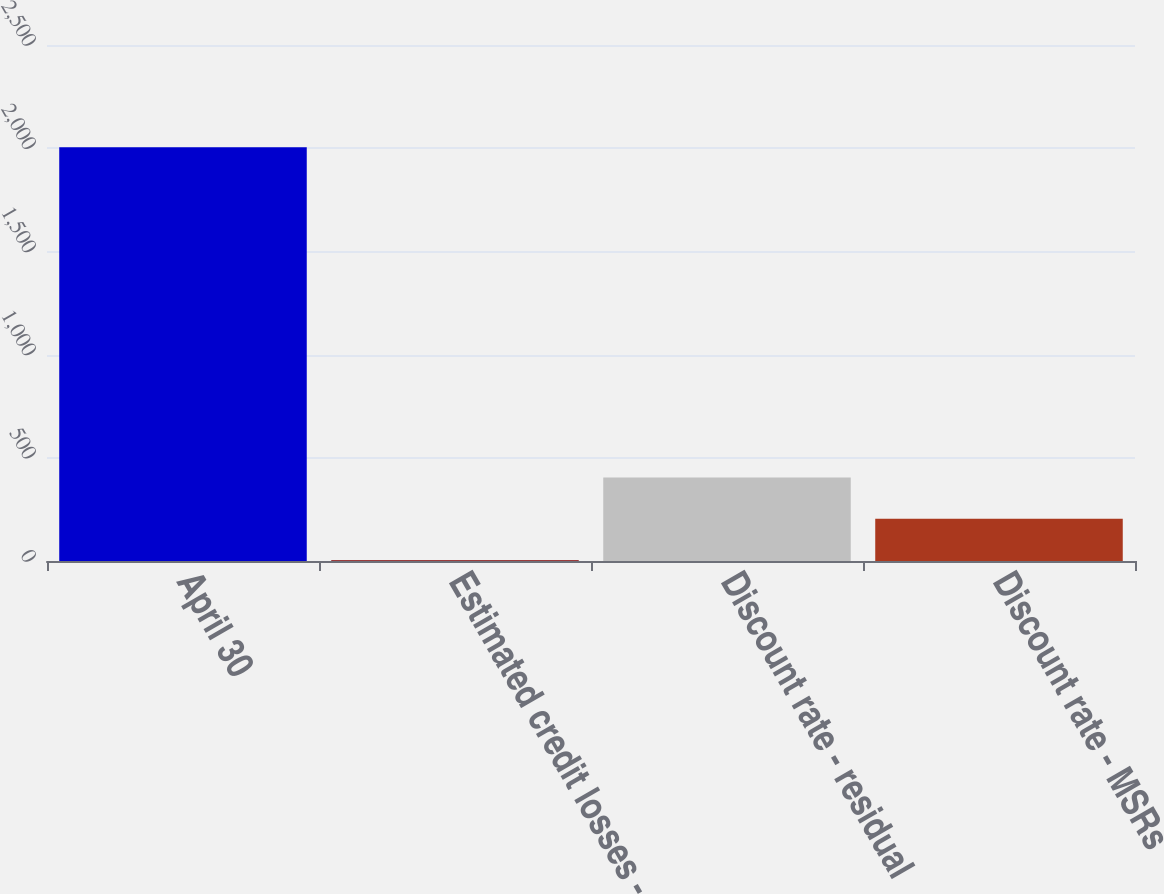<chart> <loc_0><loc_0><loc_500><loc_500><bar_chart><fcel>April 30<fcel>Estimated credit losses -<fcel>Discount rate - residual<fcel>Discount rate - MSRs<nl><fcel>2004<fcel>4.16<fcel>404.12<fcel>204.14<nl></chart> 